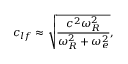<formula> <loc_0><loc_0><loc_500><loc_500>c _ { l f } \approx \sqrt { \frac { c ^ { 2 } \omega _ { R } ^ { 2 } } { \omega _ { R } ^ { 2 } + \omega _ { e } ^ { 2 } } } ,</formula> 